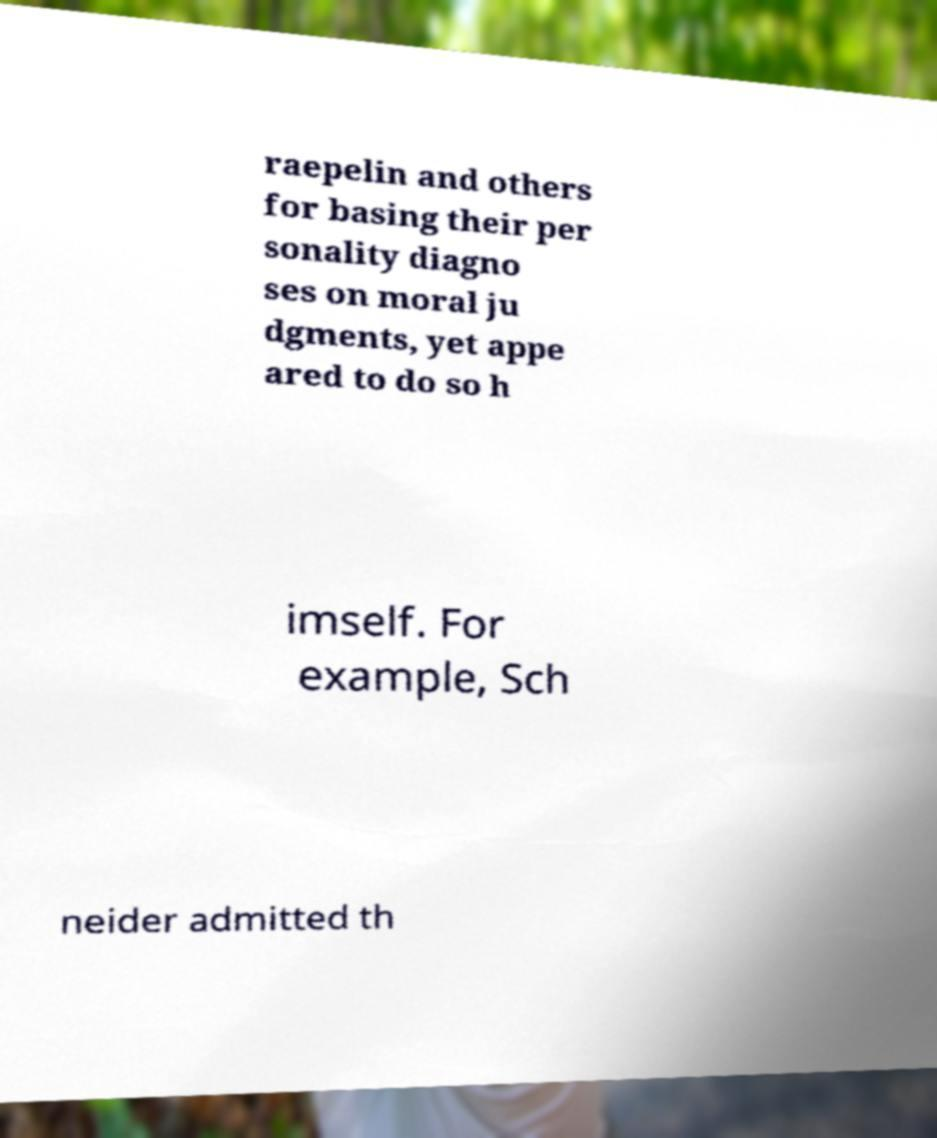Can you read and provide the text displayed in the image?This photo seems to have some interesting text. Can you extract and type it out for me? raepelin and others for basing their per sonality diagno ses on moral ju dgments, yet appe ared to do so h imself. For example, Sch neider admitted th 